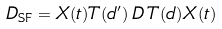Convert formula to latex. <formula><loc_0><loc_0><loc_500><loc_500>D _ { \text {SF} } = X ( t ) T ( d ^ { \prime } ) \, D \, T ( d ) X ( t )</formula> 